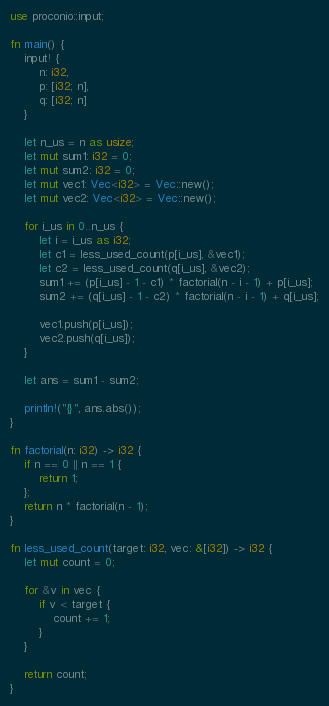Convert code to text. <code><loc_0><loc_0><loc_500><loc_500><_Rust_>use proconio::input;

fn main() {
    input! {
        n: i32,
        p: [i32; n],
        q: [i32; n]
    }

    let n_us = n as usize;
    let mut sum1: i32 = 0;
    let mut sum2: i32 = 0;
    let mut vec1: Vec<i32> = Vec::new();
    let mut vec2: Vec<i32> = Vec::new();

    for i_us in 0..n_us {
        let i = i_us as i32;
        let c1 = less_used_count(p[i_us], &vec1);
        let c2 = less_used_count(q[i_us], &vec2);
        sum1 += (p[i_us] - 1 - c1) * factorial(n - i - 1) + p[i_us];
        sum2 += (q[i_us] - 1 - c2) * factorial(n - i - 1) + q[i_us];

        vec1.push(p[i_us]);
        vec2.push(q[i_us]);
    }

    let ans = sum1 - sum2;

    println!("{}", ans.abs());
}

fn factorial(n: i32) -> i32 {
    if n == 0 || n == 1 {
        return 1;
    };
    return n * factorial(n - 1);
}

fn less_used_count(target: i32, vec: &[i32]) -> i32 {
    let mut count = 0;

    for &v in vec {
        if v < target {
            count += 1;
        }
    }

    return count;
}
</code> 